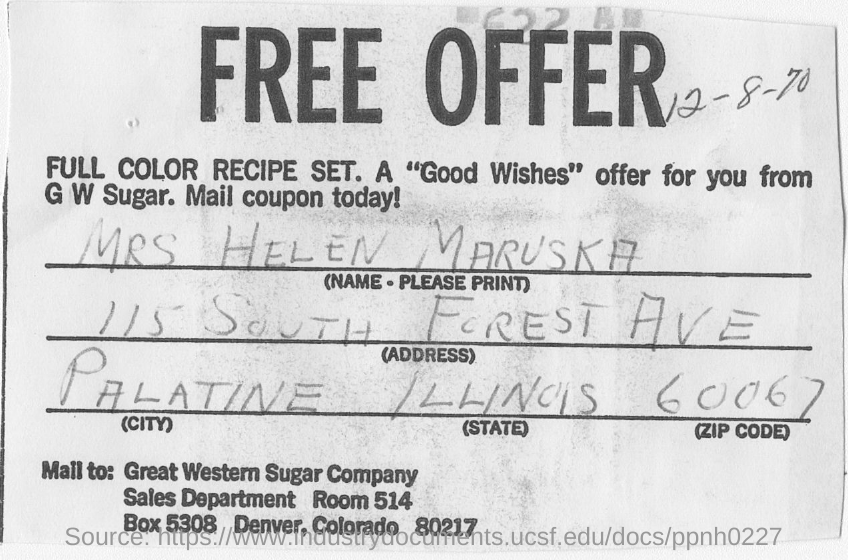Point out several critical features in this image. The Great Western Sugar Company is located in Denver, Colorado. 